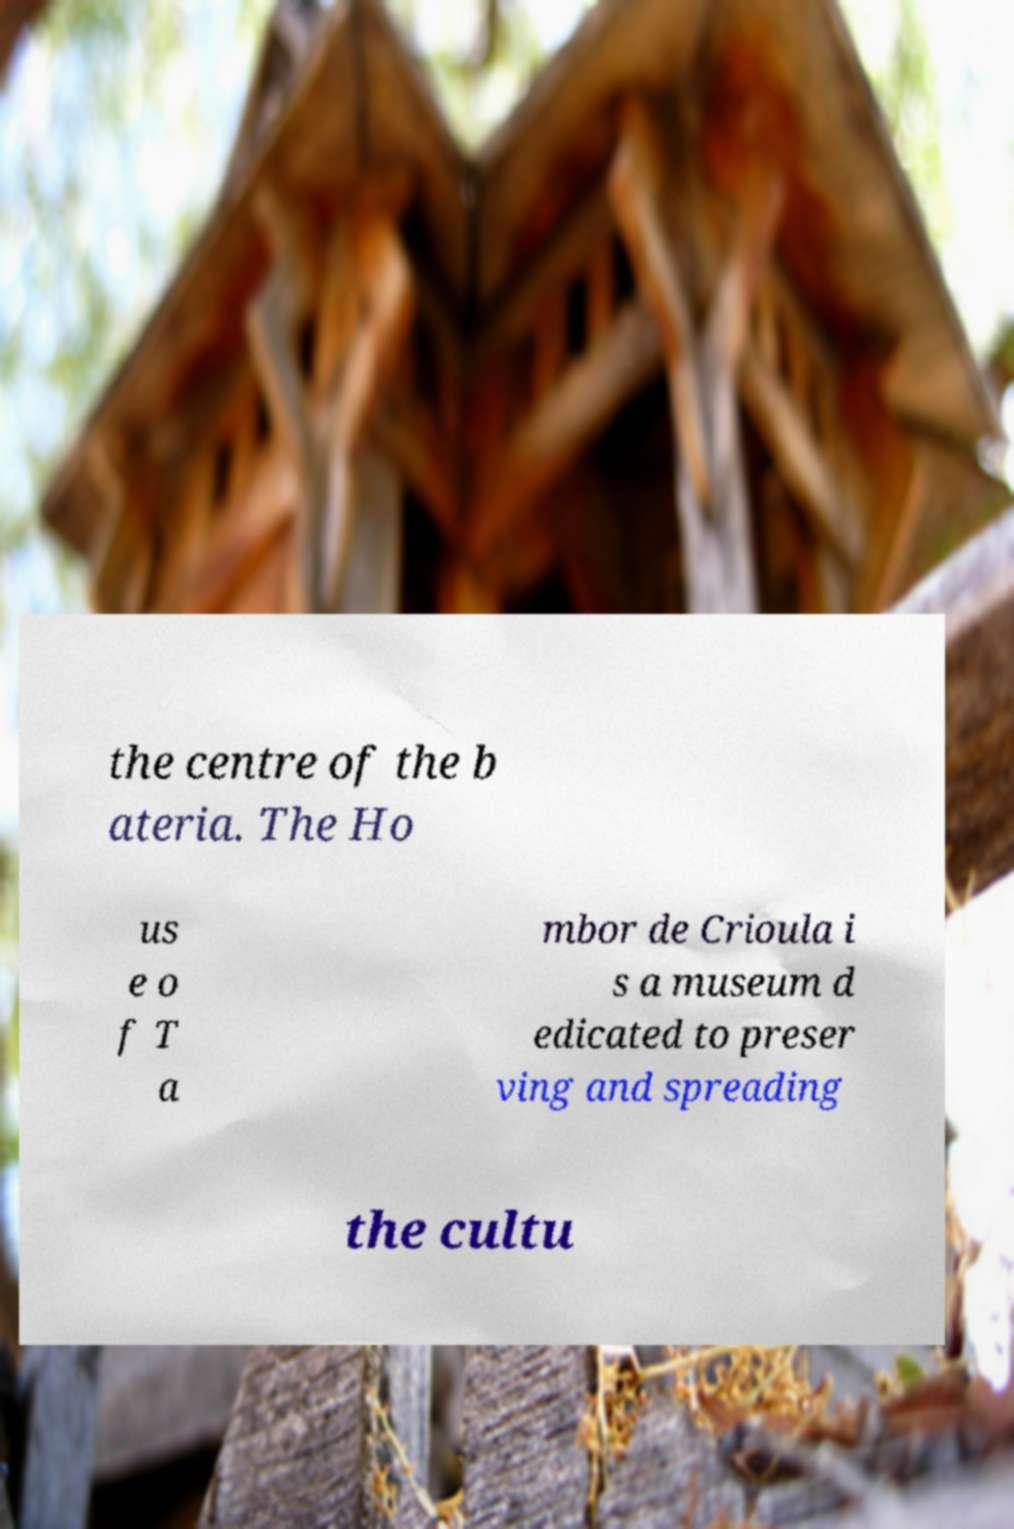Can you read and provide the text displayed in the image?This photo seems to have some interesting text. Can you extract and type it out for me? the centre of the b ateria. The Ho us e o f T a mbor de Crioula i s a museum d edicated to preser ving and spreading the cultu 